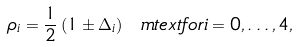Convert formula to latex. <formula><loc_0><loc_0><loc_500><loc_500>\rho _ { i } = \frac { 1 } { 2 } \left ( 1 \pm \Delta _ { i } \right ) \ m t e x t { f o r } i = 0 , \dots , 4 ,</formula> 